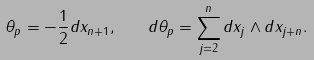Convert formula to latex. <formula><loc_0><loc_0><loc_500><loc_500>\theta _ { p } = - \frac { 1 } { 2 } d x _ { n + 1 } , \quad d \theta _ { p } = \sum _ { j = 2 } ^ { n } d x _ { j } \wedge d x _ { j + n } .</formula> 